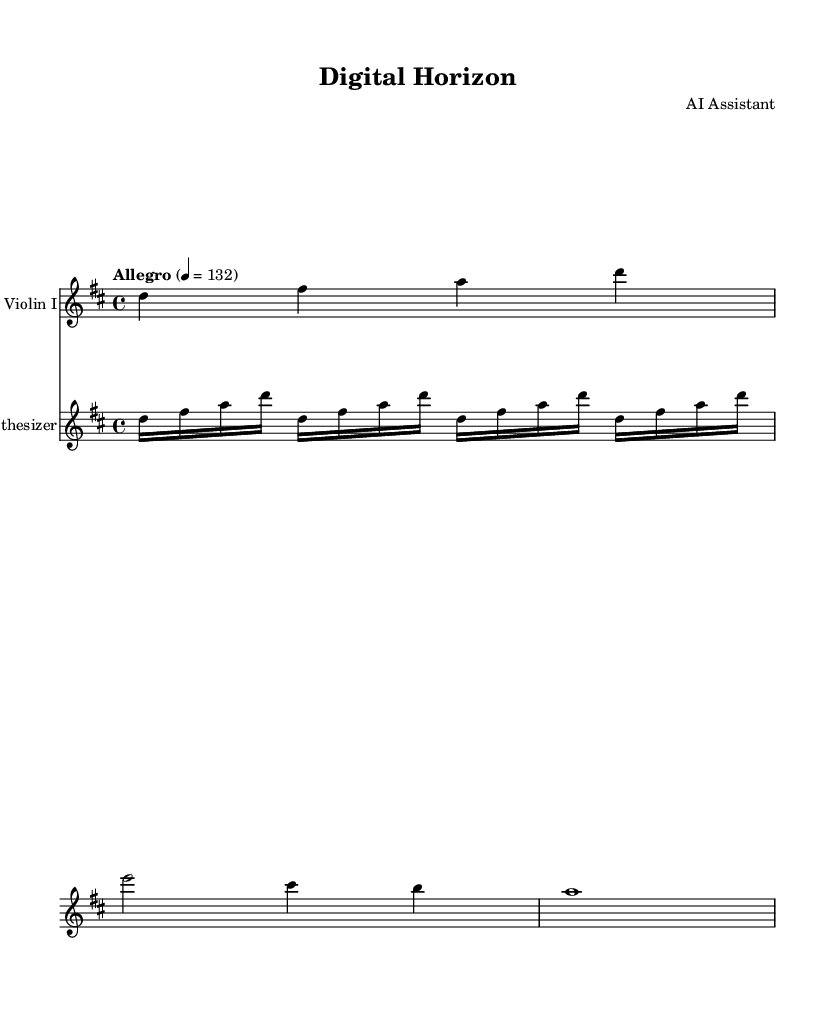What is the key signature of this music? The key signature is indicated at the beginning of the staff and shows two sharps, which correspond to F# and C#. This indicates that the piece is in D major.
Answer: D major What is the time signature of this music? The time signature is shown at the beginning of the staff as 4/4, which means there are four beats in each measure and the quarter note receives one beat.
Answer: 4/4 What is the tempo marking of this piece? The tempo marking is indicated in the score, stating "Allegro" with a metronome marking of quarter note equals 132, suggesting a lively pace.
Answer: Allegro, 132 How many measures are present in the violin part? By counting the vertical bars (bar lines) that separate the measures in the violin part, there are four measures visible in the score.
Answer: Four What compositional technique is used in the synthesizer part? The synthesizer part employs a repeated pattern of notes, indicated by the "repeat unfold" command, which showcases a sequential structure within a single phrase.
Answer: Repetition How does the melody in the violin interact with the synthesizer line? The violin plays longer, sustained notes that provide a lyrical melody, while the synthesizer adds shorter, rapid notes above it, creating a contrasting texture that enhances the modern feel of the piece.
Answer: Contrasting textures What does the title "Digital Horizon" suggest about this symphony? The title suggests a theme that is influenced by technology, hinting at an exploration of modern landscapes and the impact of digital advancements on musical composition and expression.
Answer: Technological influence 